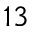<formula> <loc_0><loc_0><loc_500><loc_500>^ { 1 3 }</formula> 